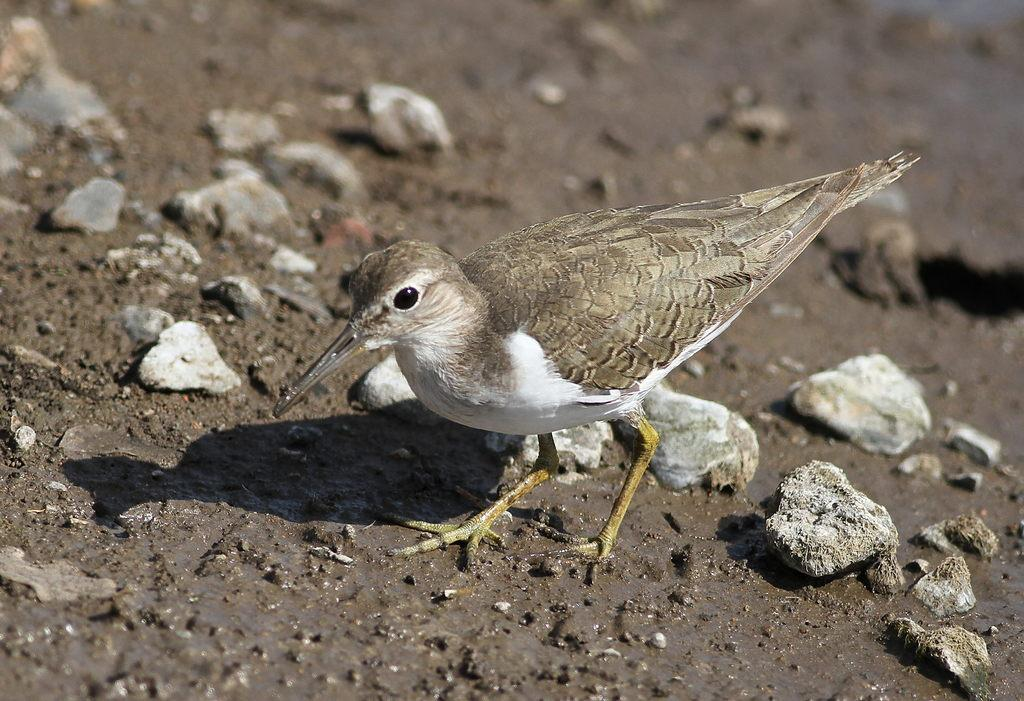What type of animal can be seen in the image? There is a bird in the image. What can be seen on the ground in the image? There are stones on the ground in the image. How many people are present in the crowd in the image? There is no crowd present in the image; it features a bird and stones on the ground. What type of party is being depicted in the image? There is no party depicted in the image; it features a bird and stones on the ground. 